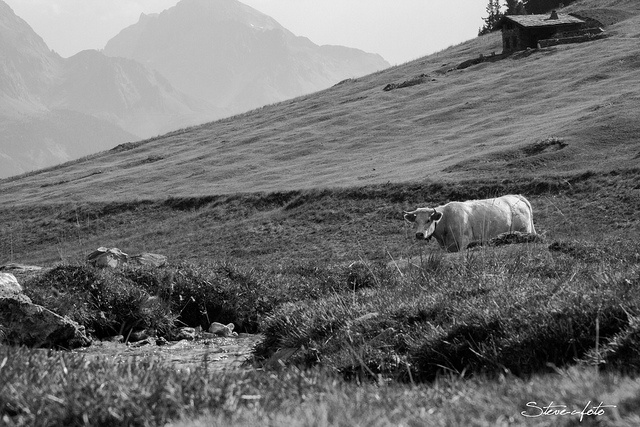Describe the objects in this image and their specific colors. I can see a cow in darkgray, gray, lightgray, and black tones in this image. 